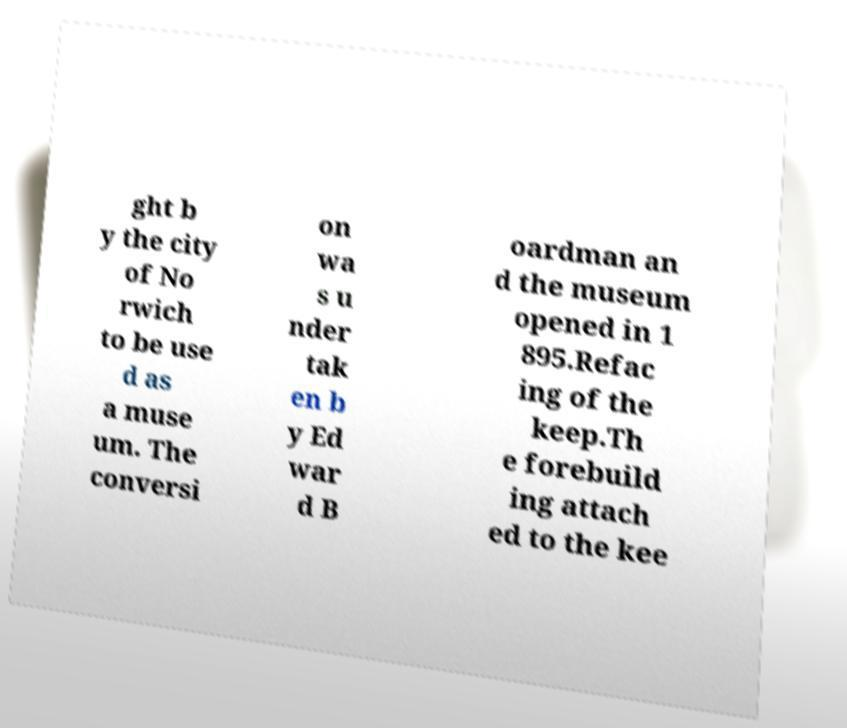Please identify and transcribe the text found in this image. ght b y the city of No rwich to be use d as a muse um. The conversi on wa s u nder tak en b y Ed war d B oardman an d the museum opened in 1 895.Refac ing of the keep.Th e forebuild ing attach ed to the kee 